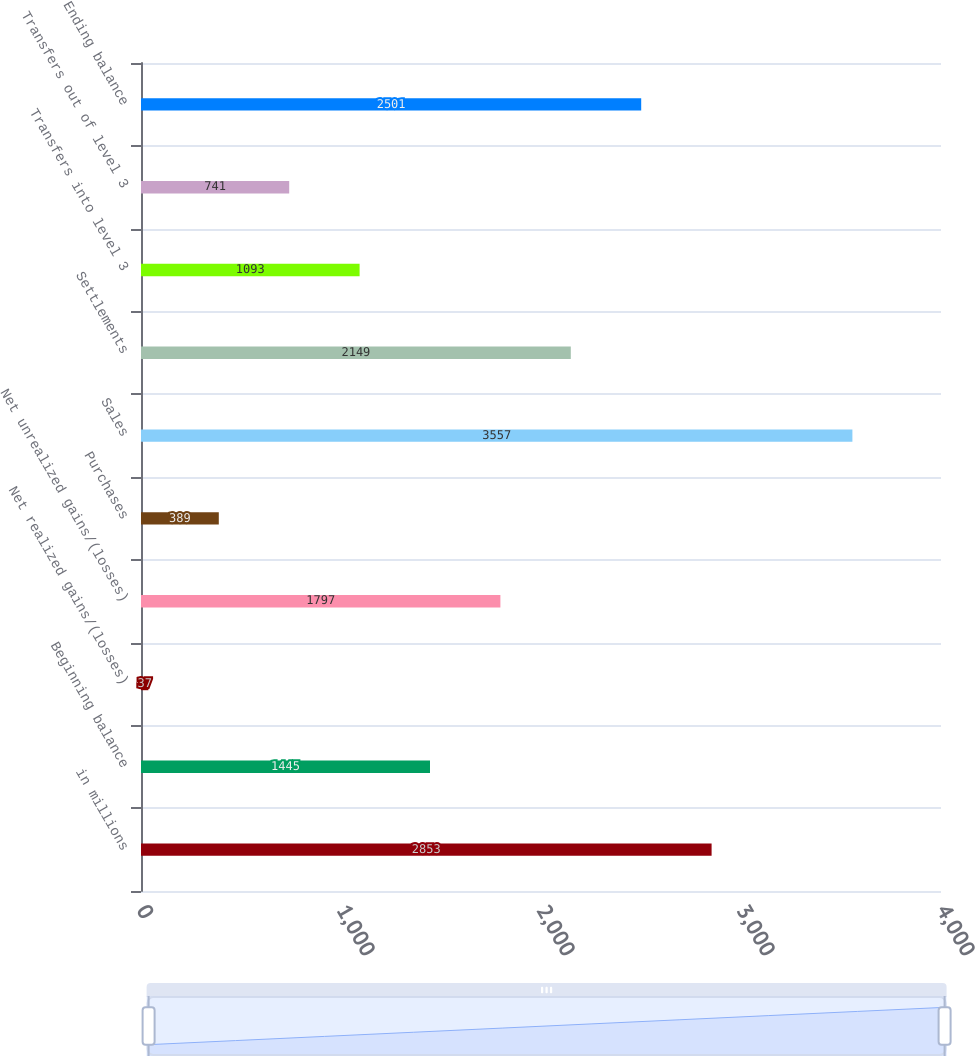Convert chart to OTSL. <chart><loc_0><loc_0><loc_500><loc_500><bar_chart><fcel>in millions<fcel>Beginning balance<fcel>Net realized gains/(losses)<fcel>Net unrealized gains/(losses)<fcel>Purchases<fcel>Sales<fcel>Settlements<fcel>Transfers into level 3<fcel>Transfers out of level 3<fcel>Ending balance<nl><fcel>2853<fcel>1445<fcel>37<fcel>1797<fcel>389<fcel>3557<fcel>2149<fcel>1093<fcel>741<fcel>2501<nl></chart> 